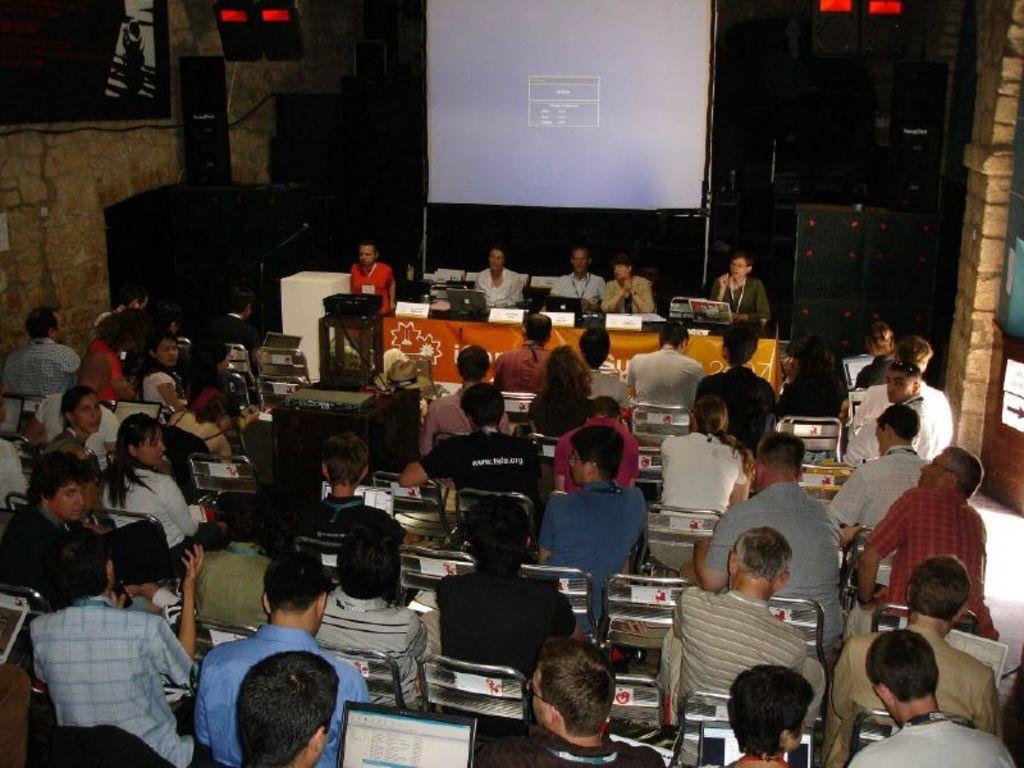Could you give a brief overview of what you see in this image? In this image there are many chairs. On the chairs many people are sitting. few are using laptop. In the background behind a table few people are sitting on chairs. On the table there are nameplates, laptops. In the background there is screen, speakers. This is looking like an entrance. 